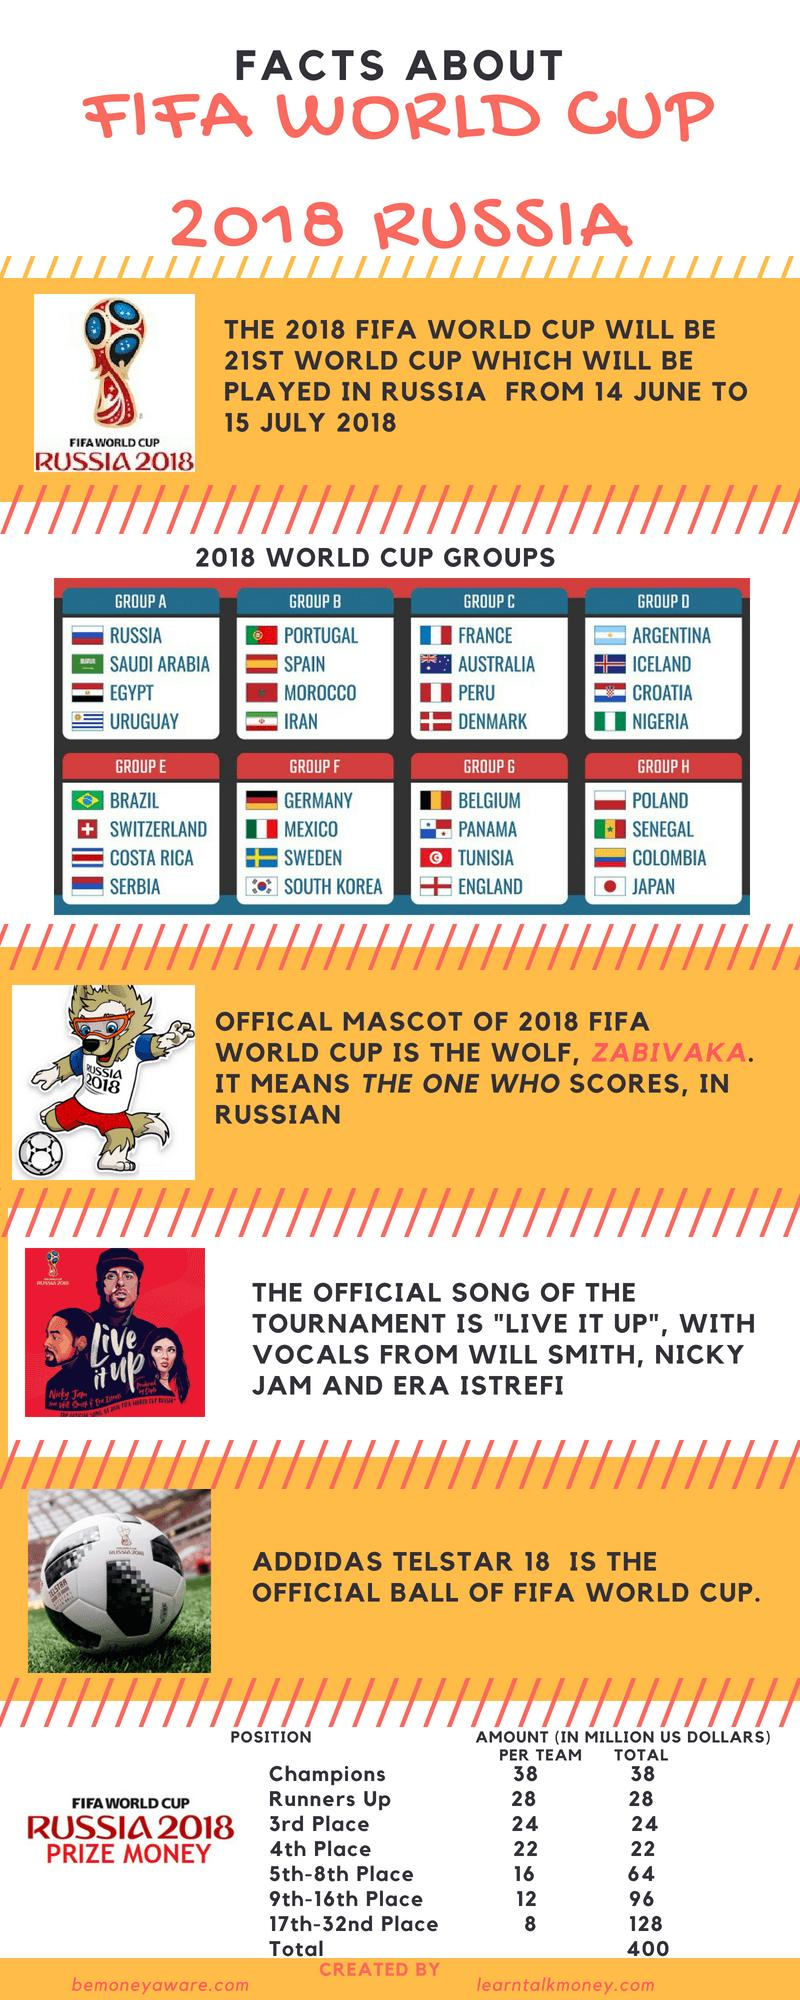Outline some significant characteristics in this image. The total prize money given to the 7th place team is approximately 16 million dollars. The first runner-up team will receive significantly less money than the champions, approximately 10 million dollars less, in million dollars. The total prize money given to the 10th place team is approximately 12 million dollars. The FIFA World Cup 2018 featured 32 participating teams. The total prize money given to the 20th place team is 8 million dollars. 